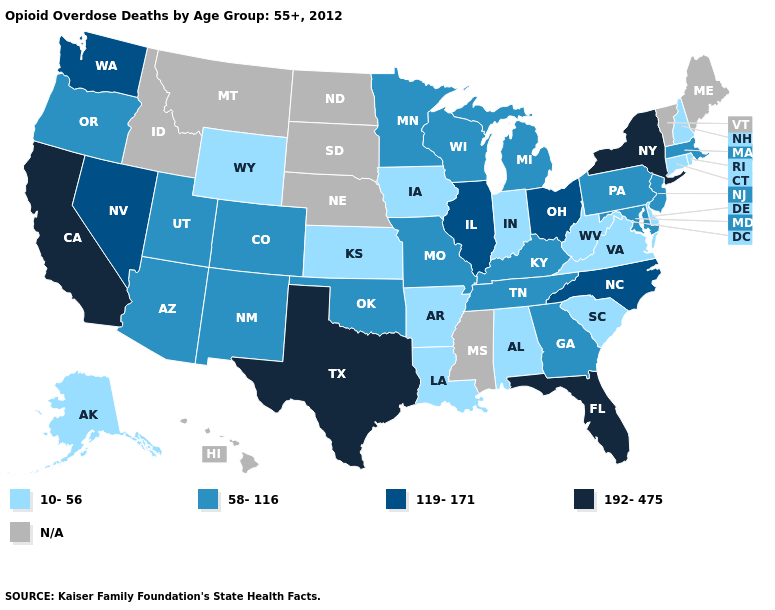Which states have the highest value in the USA?
Be succinct. California, Florida, New York, Texas. Among the states that border California , does Arizona have the highest value?
Be succinct. No. What is the value of South Dakota?
Quick response, please. N/A. Name the states that have a value in the range N/A?
Give a very brief answer. Hawaii, Idaho, Maine, Mississippi, Montana, Nebraska, North Dakota, South Dakota, Vermont. Does the first symbol in the legend represent the smallest category?
Write a very short answer. Yes. Does Alaska have the lowest value in the West?
Quick response, please. Yes. Which states have the lowest value in the West?
Write a very short answer. Alaska, Wyoming. Name the states that have a value in the range 10-56?
Give a very brief answer. Alabama, Alaska, Arkansas, Connecticut, Delaware, Indiana, Iowa, Kansas, Louisiana, New Hampshire, Rhode Island, South Carolina, Virginia, West Virginia, Wyoming. Name the states that have a value in the range 192-475?
Quick response, please. California, Florida, New York, Texas. Which states hav the highest value in the South?
Give a very brief answer. Florida, Texas. What is the value of Kansas?
Short answer required. 10-56. Among the states that border New York , which have the lowest value?
Concise answer only. Connecticut. Which states have the lowest value in the USA?
Answer briefly. Alabama, Alaska, Arkansas, Connecticut, Delaware, Indiana, Iowa, Kansas, Louisiana, New Hampshire, Rhode Island, South Carolina, Virginia, West Virginia, Wyoming. Does Texas have the highest value in the USA?
Answer briefly. Yes. 